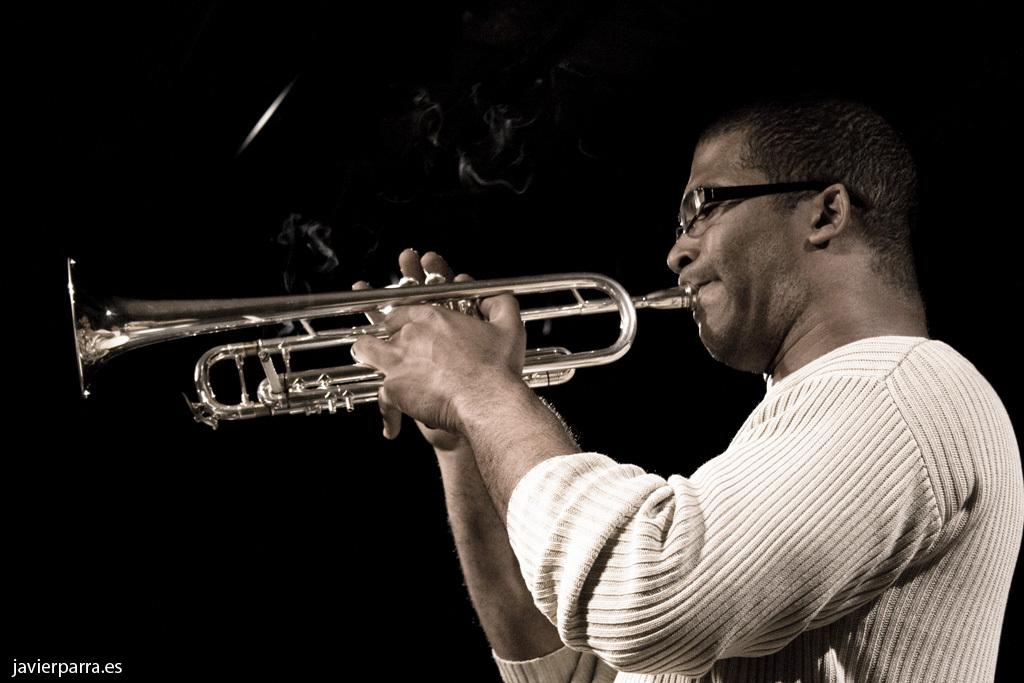What is the man in the image doing? The man is playing a trombone in the image. What is the man wearing in the image? The man is wearing a white T-shirt in the image. What can be observed about the background of the image? The background of the image is dark. What type of bell can be heard ringing in the image? There is no bell present in the image, and therefore no sound can be heard. 